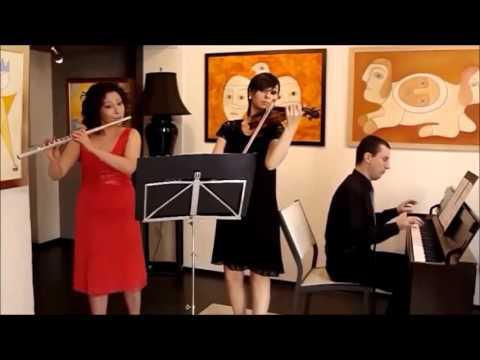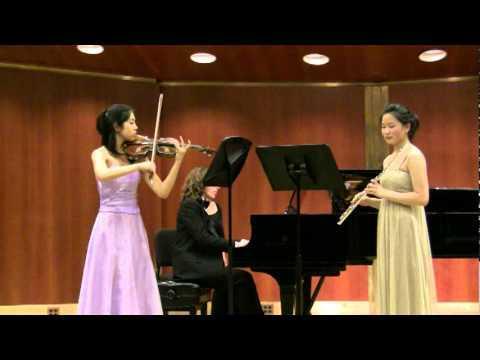The first image is the image on the left, the second image is the image on the right. For the images shown, is this caption "There are exactly six musicians playing instruments, three in each image." true? Answer yes or no. Yes. The first image is the image on the left, the second image is the image on the right. Analyze the images presented: Is the assertion "Two girls are positioned to the right of a violinist while holding a flute to their mouth." valid? Answer yes or no. No. 